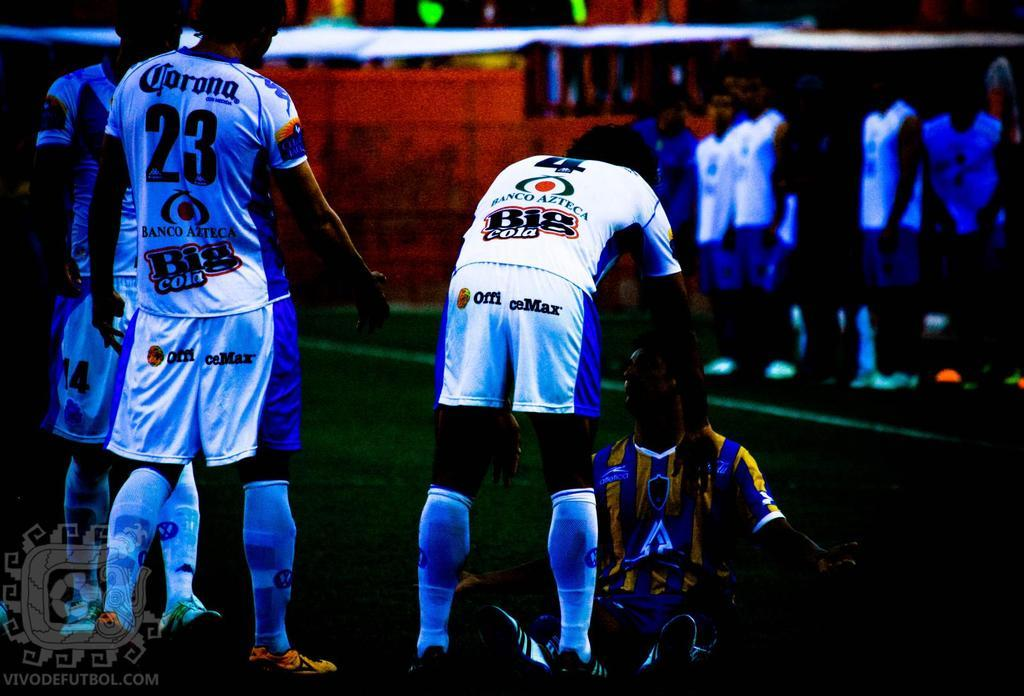<image>
Share a concise interpretation of the image provided. athletes wearing Corona sponsored jerseys are lined up, one interacting with an opposing player. 